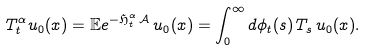<formula> <loc_0><loc_0><loc_500><loc_500>T ^ { \alpha } _ { t } u _ { 0 } ( x ) = \mathbb { E } e ^ { - \mathfrak { H } ^ { \alpha } _ { t } \, \mathcal { A } } \, u _ { 0 } ( x ) = \int _ { 0 } ^ { \infty } d \phi _ { t } ( s ) \, T _ { s } \, u _ { 0 } ( x ) .</formula> 